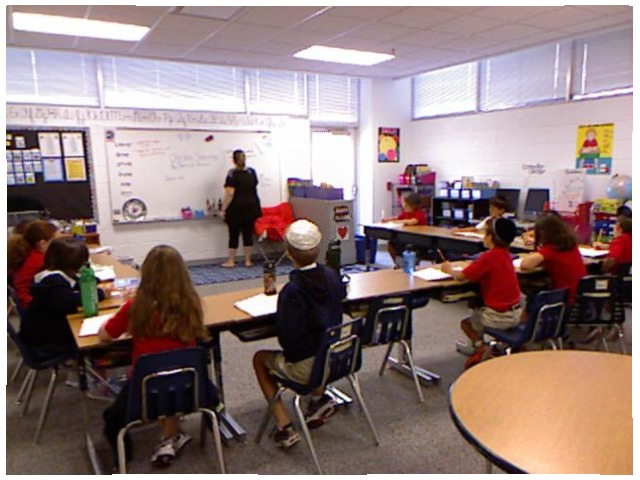<image>
Is there a teacher in front of the whiteboard? Yes. The teacher is positioned in front of the whiteboard, appearing closer to the camera viewpoint. Is there a boy on the chair? Yes. Looking at the image, I can see the boy is positioned on top of the chair, with the chair providing support. Is the student on the chair? No. The student is not positioned on the chair. They may be near each other, but the student is not supported by or resting on top of the chair. Where is the kid in relation to the chair? Is it on the chair? No. The kid is not positioned on the chair. They may be near each other, but the kid is not supported by or resting on top of the chair. Where is the boy in relation to the girl? Is it to the left of the girl? No. The boy is not to the left of the girl. From this viewpoint, they have a different horizontal relationship. Where is the chair in relation to the woman? Is it to the right of the woman? Yes. From this viewpoint, the chair is positioned to the right side relative to the woman. Is the table to the right of the student? No. The table is not to the right of the student. The horizontal positioning shows a different relationship. Where is the girl in relation to the boy? Is it to the right of the boy? No. The girl is not to the right of the boy. The horizontal positioning shows a different relationship. Is the student next to the teacher? No. The student is not positioned next to the teacher. They are located in different areas of the scene. 